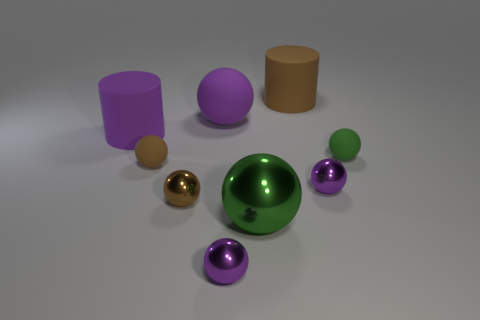Subtract all blue cubes. How many purple balls are left? 3 Subtract all brown balls. How many balls are left? 5 Subtract all small brown balls. How many balls are left? 5 Subtract 3 spheres. How many spheres are left? 4 Subtract all purple spheres. Subtract all cyan cylinders. How many spheres are left? 4 Subtract all cylinders. How many objects are left? 7 Subtract all rubber objects. Subtract all purple rubber objects. How many objects are left? 2 Add 1 big green metal things. How many big green metal things are left? 2 Add 8 purple matte things. How many purple matte things exist? 10 Subtract 0 brown cubes. How many objects are left? 9 